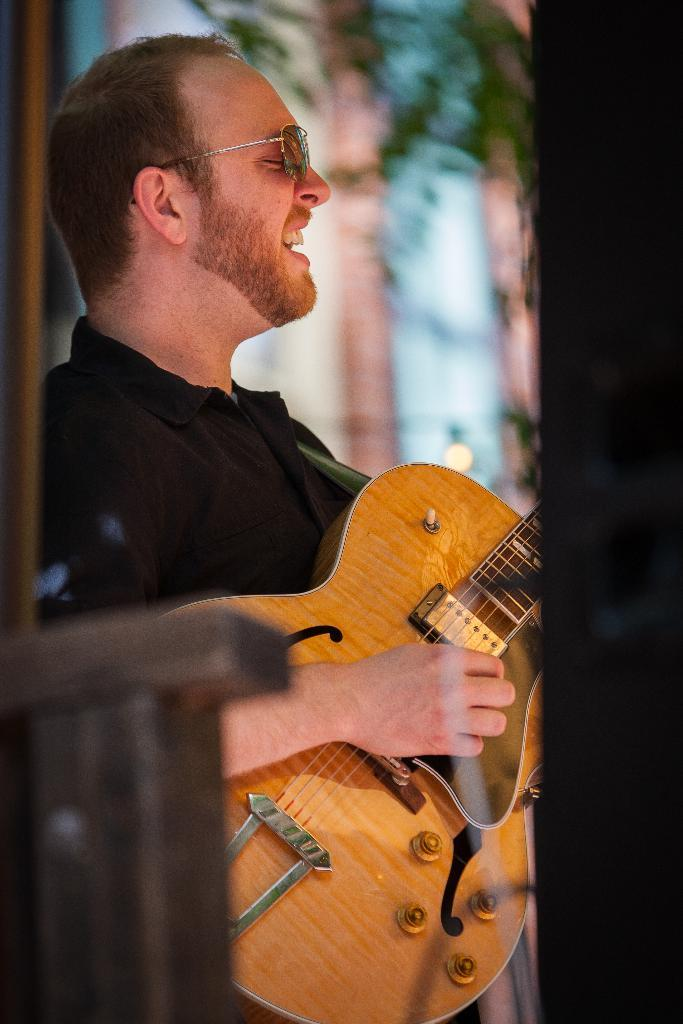Who is the main subject in the image? There is a person in the image. What is the person wearing? The person is wearing a black shirt. What activity is the person engaged in? The person is playing a guitar and singing. How many letters are being written by the person in the image? There is no indication in the image that the person is writing any letters, as they are playing a guitar and singing. 